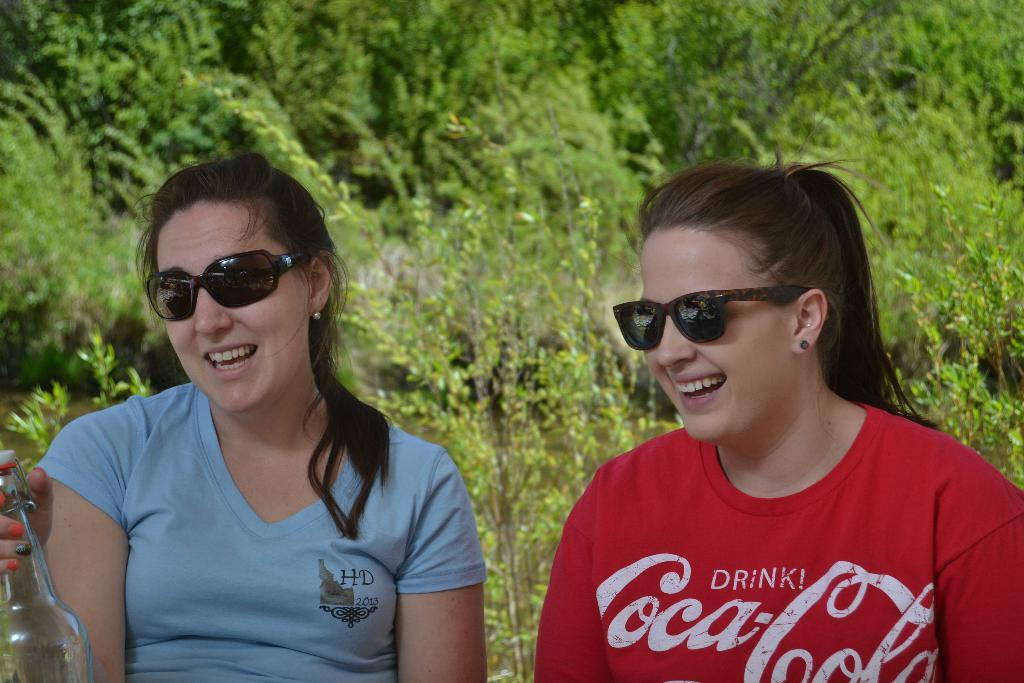How many women are in the image? There are two women in the image. What expressions do the women have? Both women are smiling. What are the women wearing on their faces? The women are wearing goggles. What is one of the women holding? One of the women is holding a bottle. What can be seen in the background of the image? There are plants and trees in the background of the image. What type of cars can be seen in the image? There are no cars present in the image. What achievements have the women accomplished, as depicted in the image? The image does not provide any information about the women's achievements. 